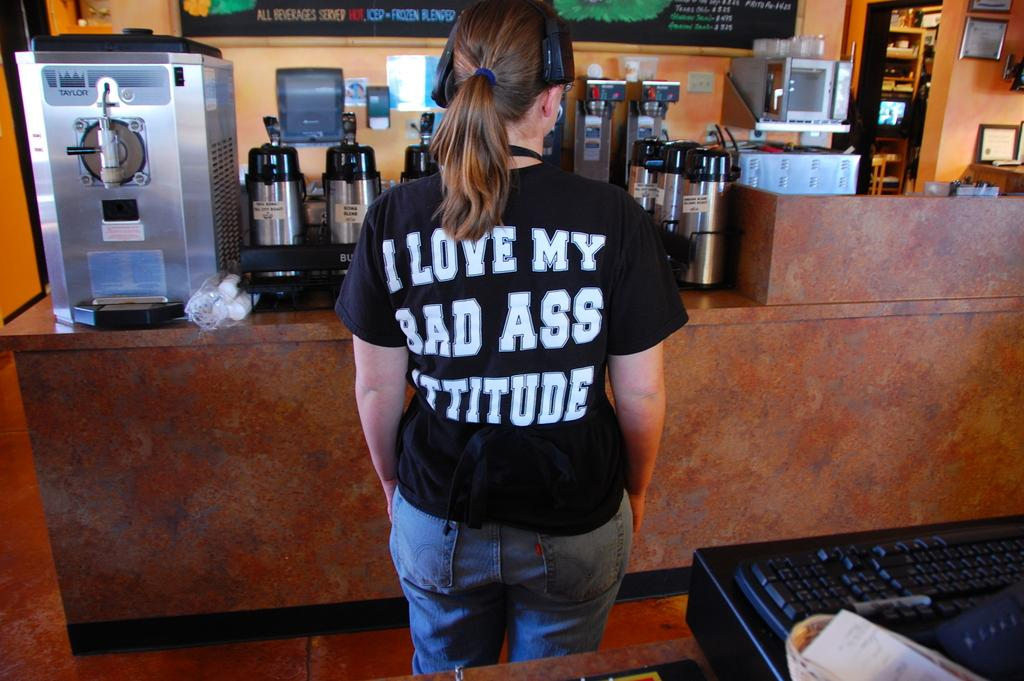<image>
Present a compact description of the photo's key features. An employee in a cafe shows off the saying on her shirt "I love my bad ass attitutde". 